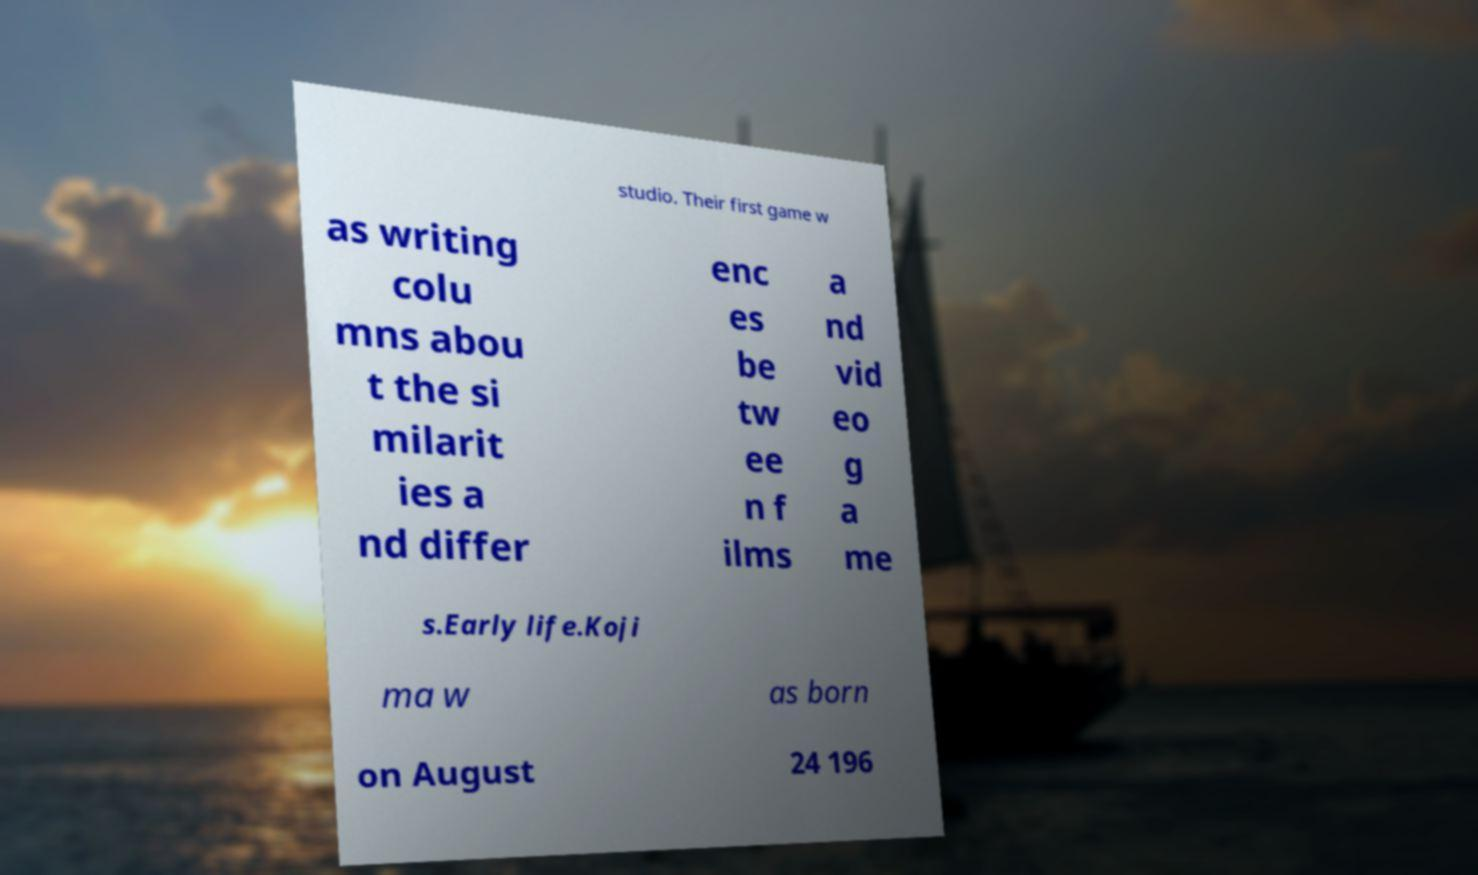There's text embedded in this image that I need extracted. Can you transcribe it verbatim? studio. Their first game w as writing colu mns abou t the si milarit ies a nd differ enc es be tw ee n f ilms a nd vid eo g a me s.Early life.Koji ma w as born on August 24 196 